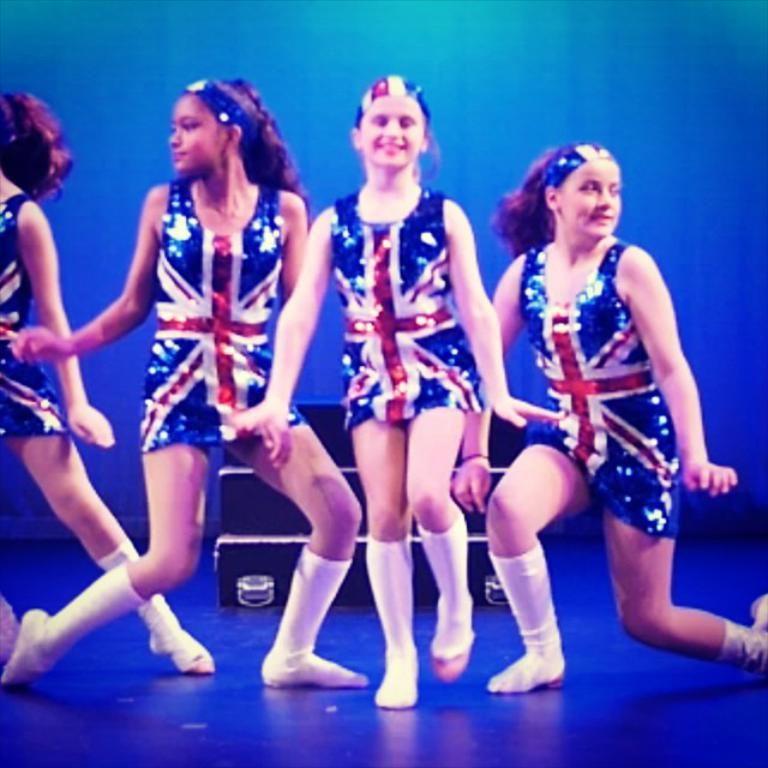Who is present in the image? There are girls in the image. What are the girls wearing? The girls are wearing colorful dresses. What can be seen on the floor in the image? Socks are visible on the floor. What is located in the background of the image? There is an object in the background of the image. What type of fence is visible in the background of the image? There is a blue color fence in the background of the image. Is there any quicksand visible in the image? No, there is no quicksand present in the image. What type of oven can be seen in the image? There is no oven visible in the image. 